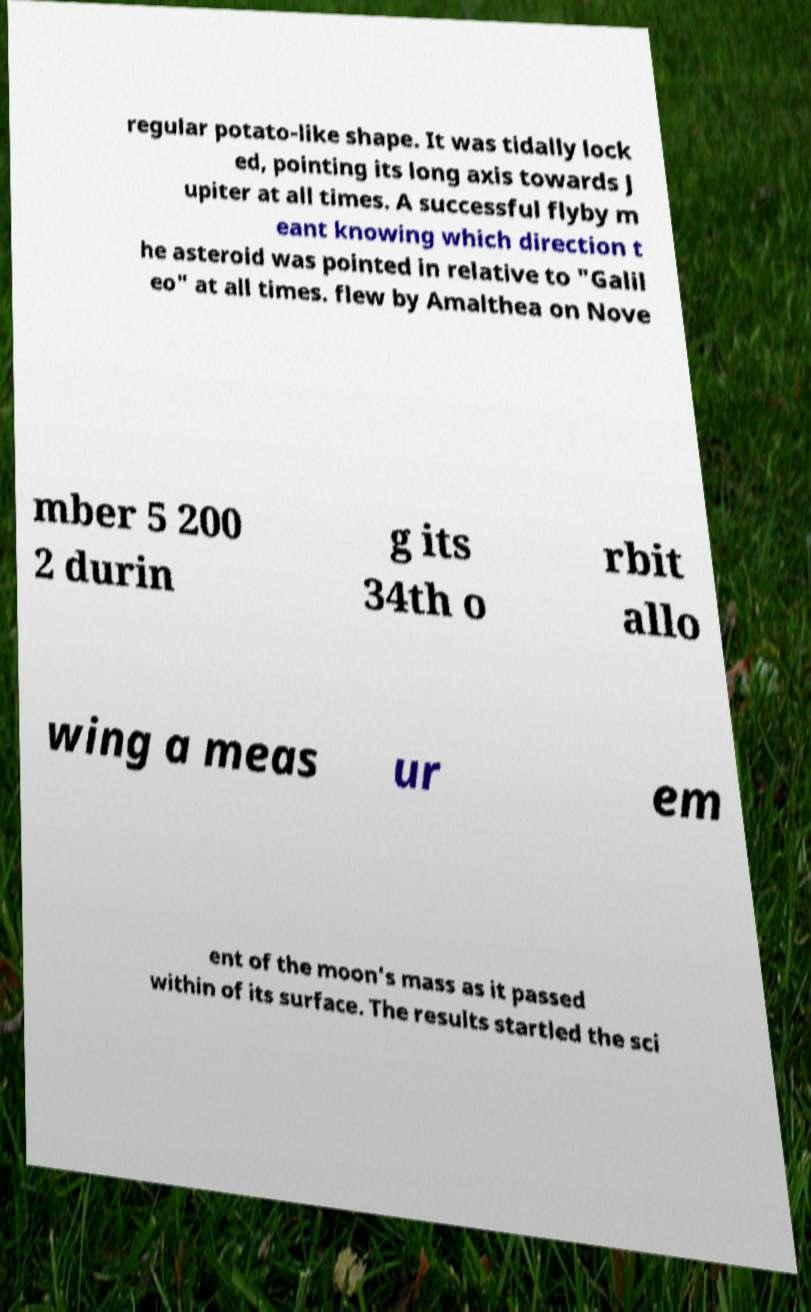What messages or text are displayed in this image? I need them in a readable, typed format. regular potato-like shape. It was tidally lock ed, pointing its long axis towards J upiter at all times. A successful flyby m eant knowing which direction t he asteroid was pointed in relative to "Galil eo" at all times. flew by Amalthea on Nove mber 5 200 2 durin g its 34th o rbit allo wing a meas ur em ent of the moon's mass as it passed within of its surface. The results startled the sci 